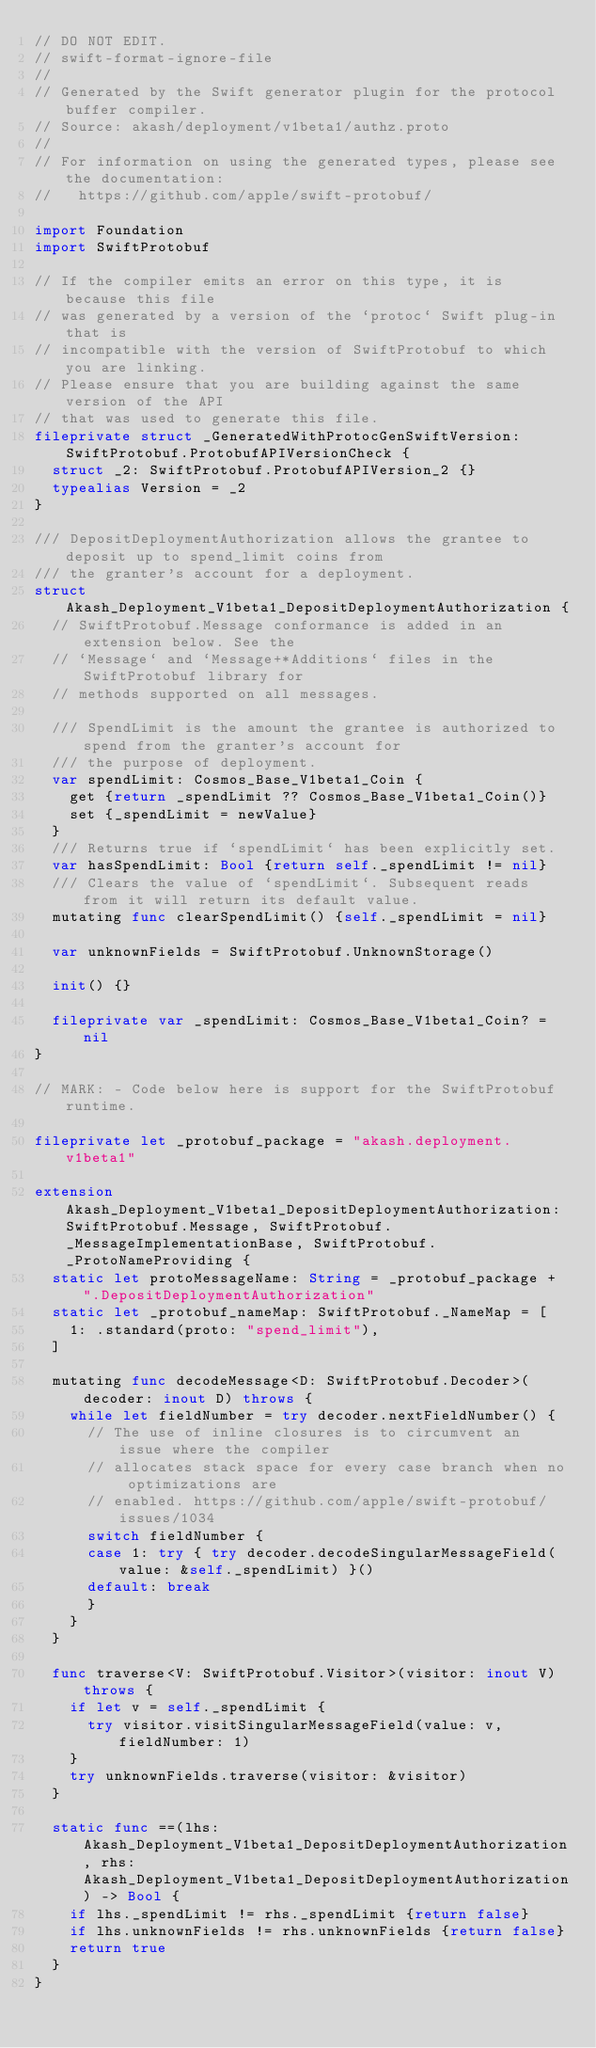Convert code to text. <code><loc_0><loc_0><loc_500><loc_500><_Swift_>// DO NOT EDIT.
// swift-format-ignore-file
//
// Generated by the Swift generator plugin for the protocol buffer compiler.
// Source: akash/deployment/v1beta1/authz.proto
//
// For information on using the generated types, please see the documentation:
//   https://github.com/apple/swift-protobuf/

import Foundation
import SwiftProtobuf

// If the compiler emits an error on this type, it is because this file
// was generated by a version of the `protoc` Swift plug-in that is
// incompatible with the version of SwiftProtobuf to which you are linking.
// Please ensure that you are building against the same version of the API
// that was used to generate this file.
fileprivate struct _GeneratedWithProtocGenSwiftVersion: SwiftProtobuf.ProtobufAPIVersionCheck {
  struct _2: SwiftProtobuf.ProtobufAPIVersion_2 {}
  typealias Version = _2
}

/// DepositDeploymentAuthorization allows the grantee to deposit up to spend_limit coins from
/// the granter's account for a deployment.
struct Akash_Deployment_V1beta1_DepositDeploymentAuthorization {
  // SwiftProtobuf.Message conformance is added in an extension below. See the
  // `Message` and `Message+*Additions` files in the SwiftProtobuf library for
  // methods supported on all messages.

  /// SpendLimit is the amount the grantee is authorized to spend from the granter's account for
  /// the purpose of deployment.
  var spendLimit: Cosmos_Base_V1beta1_Coin {
    get {return _spendLimit ?? Cosmos_Base_V1beta1_Coin()}
    set {_spendLimit = newValue}
  }
  /// Returns true if `spendLimit` has been explicitly set.
  var hasSpendLimit: Bool {return self._spendLimit != nil}
  /// Clears the value of `spendLimit`. Subsequent reads from it will return its default value.
  mutating func clearSpendLimit() {self._spendLimit = nil}

  var unknownFields = SwiftProtobuf.UnknownStorage()

  init() {}

  fileprivate var _spendLimit: Cosmos_Base_V1beta1_Coin? = nil
}

// MARK: - Code below here is support for the SwiftProtobuf runtime.

fileprivate let _protobuf_package = "akash.deployment.v1beta1"

extension Akash_Deployment_V1beta1_DepositDeploymentAuthorization: SwiftProtobuf.Message, SwiftProtobuf._MessageImplementationBase, SwiftProtobuf._ProtoNameProviding {
  static let protoMessageName: String = _protobuf_package + ".DepositDeploymentAuthorization"
  static let _protobuf_nameMap: SwiftProtobuf._NameMap = [
    1: .standard(proto: "spend_limit"),
  ]

  mutating func decodeMessage<D: SwiftProtobuf.Decoder>(decoder: inout D) throws {
    while let fieldNumber = try decoder.nextFieldNumber() {
      // The use of inline closures is to circumvent an issue where the compiler
      // allocates stack space for every case branch when no optimizations are
      // enabled. https://github.com/apple/swift-protobuf/issues/1034
      switch fieldNumber {
      case 1: try { try decoder.decodeSingularMessageField(value: &self._spendLimit) }()
      default: break
      }
    }
  }

  func traverse<V: SwiftProtobuf.Visitor>(visitor: inout V) throws {
    if let v = self._spendLimit {
      try visitor.visitSingularMessageField(value: v, fieldNumber: 1)
    }
    try unknownFields.traverse(visitor: &visitor)
  }

  static func ==(lhs: Akash_Deployment_V1beta1_DepositDeploymentAuthorization, rhs: Akash_Deployment_V1beta1_DepositDeploymentAuthorization) -> Bool {
    if lhs._spendLimit != rhs._spendLimit {return false}
    if lhs.unknownFields != rhs.unknownFields {return false}
    return true
  }
}
</code> 